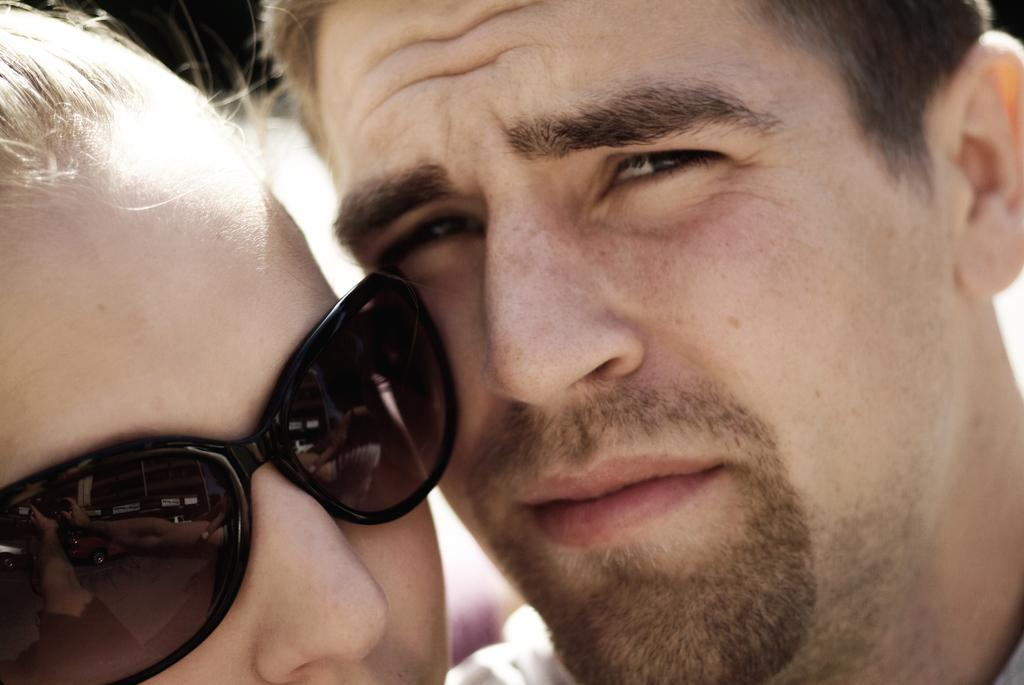Who is present in the image? There is a man and a woman in the image. What are the man and the woman doing in the image? The man and the woman are taking pictures. What type of sticks are being used by the man and the woman to record their memories? There is no mention of sticks or recording devices in the image; the man and the woman are taking pictures. 